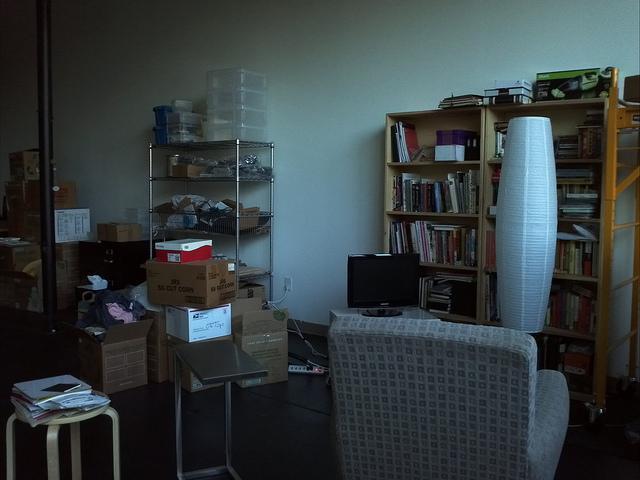How many bookcases are in the room?
Give a very brief answer. 2. 